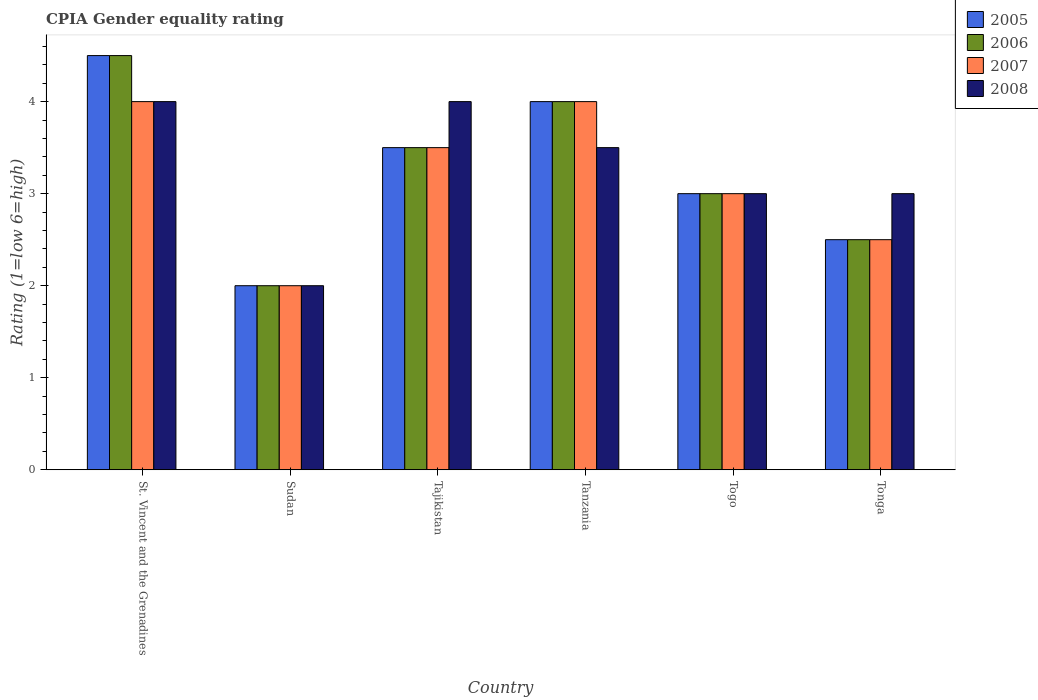How many groups of bars are there?
Keep it short and to the point. 6. How many bars are there on the 5th tick from the right?
Give a very brief answer. 4. What is the label of the 5th group of bars from the left?
Your answer should be very brief. Togo. In which country was the CPIA rating in 2007 maximum?
Provide a short and direct response. St. Vincent and the Grenadines. In which country was the CPIA rating in 2007 minimum?
Make the answer very short. Sudan. What is the total CPIA rating in 2007 in the graph?
Offer a very short reply. 19. What is the difference between the CPIA rating in 2007 in Sudan and that in Tanzania?
Provide a short and direct response. -2. What is the difference between the CPIA rating in 2006 in Sudan and the CPIA rating in 2007 in Tanzania?
Offer a terse response. -2. What is the average CPIA rating in 2006 per country?
Give a very brief answer. 3.25. What is the ratio of the CPIA rating in 2005 in Sudan to that in Tonga?
Offer a very short reply. 0.8. In how many countries, is the CPIA rating in 2005 greater than the average CPIA rating in 2005 taken over all countries?
Provide a succinct answer. 3. What does the 2nd bar from the left in St. Vincent and the Grenadines represents?
Keep it short and to the point. 2006. What does the 2nd bar from the right in Tonga represents?
Ensure brevity in your answer.  2007. Is it the case that in every country, the sum of the CPIA rating in 2007 and CPIA rating in 2006 is greater than the CPIA rating in 2008?
Provide a short and direct response. Yes. Does the graph contain grids?
Offer a very short reply. No. How many legend labels are there?
Your answer should be very brief. 4. What is the title of the graph?
Offer a very short reply. CPIA Gender equality rating. Does "2007" appear as one of the legend labels in the graph?
Your response must be concise. Yes. What is the label or title of the X-axis?
Your answer should be very brief. Country. What is the label or title of the Y-axis?
Your answer should be very brief. Rating (1=low 6=high). What is the Rating (1=low 6=high) in 2005 in St. Vincent and the Grenadines?
Ensure brevity in your answer.  4.5. What is the Rating (1=low 6=high) of 2006 in Sudan?
Ensure brevity in your answer.  2. What is the Rating (1=low 6=high) in 2007 in Sudan?
Provide a succinct answer. 2. What is the Rating (1=low 6=high) of 2008 in Sudan?
Provide a short and direct response. 2. What is the Rating (1=low 6=high) of 2005 in Tajikistan?
Offer a very short reply. 3.5. What is the Rating (1=low 6=high) in 2006 in Tanzania?
Keep it short and to the point. 4. What is the Rating (1=low 6=high) in 2007 in Tanzania?
Give a very brief answer. 4. What is the Rating (1=low 6=high) in 2008 in Tanzania?
Your response must be concise. 3.5. What is the Rating (1=low 6=high) in 2005 in Togo?
Provide a short and direct response. 3. What is the Rating (1=low 6=high) of 2008 in Togo?
Offer a terse response. 3. What is the Rating (1=low 6=high) of 2005 in Tonga?
Your answer should be compact. 2.5. Across all countries, what is the maximum Rating (1=low 6=high) of 2006?
Keep it short and to the point. 4.5. Across all countries, what is the maximum Rating (1=low 6=high) of 2007?
Offer a terse response. 4. Across all countries, what is the minimum Rating (1=low 6=high) in 2008?
Your answer should be compact. 2. What is the total Rating (1=low 6=high) in 2005 in the graph?
Your response must be concise. 19.5. What is the total Rating (1=low 6=high) of 2006 in the graph?
Your answer should be very brief. 19.5. What is the total Rating (1=low 6=high) of 2008 in the graph?
Your answer should be very brief. 19.5. What is the difference between the Rating (1=low 6=high) of 2005 in St. Vincent and the Grenadines and that in Sudan?
Offer a very short reply. 2.5. What is the difference between the Rating (1=low 6=high) in 2006 in St. Vincent and the Grenadines and that in Sudan?
Offer a terse response. 2.5. What is the difference between the Rating (1=low 6=high) in 2008 in St. Vincent and the Grenadines and that in Sudan?
Your answer should be compact. 2. What is the difference between the Rating (1=low 6=high) of 2005 in St. Vincent and the Grenadines and that in Tajikistan?
Ensure brevity in your answer.  1. What is the difference between the Rating (1=low 6=high) in 2006 in St. Vincent and the Grenadines and that in Tajikistan?
Give a very brief answer. 1. What is the difference between the Rating (1=low 6=high) in 2005 in St. Vincent and the Grenadines and that in Tanzania?
Your response must be concise. 0.5. What is the difference between the Rating (1=low 6=high) of 2006 in St. Vincent and the Grenadines and that in Tanzania?
Offer a very short reply. 0.5. What is the difference between the Rating (1=low 6=high) in 2007 in St. Vincent and the Grenadines and that in Tanzania?
Provide a short and direct response. 0. What is the difference between the Rating (1=low 6=high) in 2005 in St. Vincent and the Grenadines and that in Togo?
Give a very brief answer. 1.5. What is the difference between the Rating (1=low 6=high) in 2006 in St. Vincent and the Grenadines and that in Togo?
Keep it short and to the point. 1.5. What is the difference between the Rating (1=low 6=high) of 2007 in St. Vincent and the Grenadines and that in Togo?
Provide a short and direct response. 1. What is the difference between the Rating (1=low 6=high) in 2008 in St. Vincent and the Grenadines and that in Togo?
Keep it short and to the point. 1. What is the difference between the Rating (1=low 6=high) of 2007 in St. Vincent and the Grenadines and that in Tonga?
Your answer should be very brief. 1.5. What is the difference between the Rating (1=low 6=high) in 2008 in St. Vincent and the Grenadines and that in Tonga?
Offer a terse response. 1. What is the difference between the Rating (1=low 6=high) of 2005 in Sudan and that in Tajikistan?
Your answer should be very brief. -1.5. What is the difference between the Rating (1=low 6=high) in 2007 in Sudan and that in Tajikistan?
Offer a terse response. -1.5. What is the difference between the Rating (1=low 6=high) in 2008 in Sudan and that in Tajikistan?
Your answer should be very brief. -2. What is the difference between the Rating (1=low 6=high) of 2005 in Sudan and that in Tanzania?
Your answer should be compact. -2. What is the difference between the Rating (1=low 6=high) of 2007 in Sudan and that in Tanzania?
Give a very brief answer. -2. What is the difference between the Rating (1=low 6=high) in 2007 in Sudan and that in Togo?
Make the answer very short. -1. What is the difference between the Rating (1=low 6=high) of 2008 in Sudan and that in Togo?
Your answer should be compact. -1. What is the difference between the Rating (1=low 6=high) of 2005 in Sudan and that in Tonga?
Keep it short and to the point. -0.5. What is the difference between the Rating (1=low 6=high) of 2006 in Sudan and that in Tonga?
Ensure brevity in your answer.  -0.5. What is the difference between the Rating (1=low 6=high) in 2007 in Sudan and that in Tonga?
Ensure brevity in your answer.  -0.5. What is the difference between the Rating (1=low 6=high) in 2005 in Tajikistan and that in Tanzania?
Provide a short and direct response. -0.5. What is the difference between the Rating (1=low 6=high) in 2008 in Tajikistan and that in Togo?
Offer a very short reply. 1. What is the difference between the Rating (1=low 6=high) of 2005 in Tajikistan and that in Tonga?
Your answer should be very brief. 1. What is the difference between the Rating (1=low 6=high) of 2006 in Tajikistan and that in Tonga?
Provide a short and direct response. 1. What is the difference between the Rating (1=low 6=high) in 2007 in Tajikistan and that in Tonga?
Make the answer very short. 1. What is the difference between the Rating (1=low 6=high) in 2005 in Tanzania and that in Togo?
Provide a short and direct response. 1. What is the difference between the Rating (1=low 6=high) of 2007 in Tanzania and that in Togo?
Give a very brief answer. 1. What is the difference between the Rating (1=low 6=high) in 2008 in Tanzania and that in Togo?
Offer a terse response. 0.5. What is the difference between the Rating (1=low 6=high) of 2006 in Tanzania and that in Tonga?
Your answer should be compact. 1.5. What is the difference between the Rating (1=low 6=high) of 2005 in Togo and that in Tonga?
Make the answer very short. 0.5. What is the difference between the Rating (1=low 6=high) in 2005 in St. Vincent and the Grenadines and the Rating (1=low 6=high) in 2008 in Sudan?
Your response must be concise. 2.5. What is the difference between the Rating (1=low 6=high) in 2006 in St. Vincent and the Grenadines and the Rating (1=low 6=high) in 2007 in Sudan?
Offer a terse response. 2.5. What is the difference between the Rating (1=low 6=high) in 2007 in St. Vincent and the Grenadines and the Rating (1=low 6=high) in 2008 in Sudan?
Provide a succinct answer. 2. What is the difference between the Rating (1=low 6=high) in 2005 in St. Vincent and the Grenadines and the Rating (1=low 6=high) in 2006 in Tajikistan?
Your response must be concise. 1. What is the difference between the Rating (1=low 6=high) in 2005 in St. Vincent and the Grenadines and the Rating (1=low 6=high) in 2008 in Tajikistan?
Make the answer very short. 0.5. What is the difference between the Rating (1=low 6=high) in 2006 in St. Vincent and the Grenadines and the Rating (1=low 6=high) in 2007 in Tajikistan?
Keep it short and to the point. 1. What is the difference between the Rating (1=low 6=high) of 2006 in St. Vincent and the Grenadines and the Rating (1=low 6=high) of 2008 in Tajikistan?
Ensure brevity in your answer.  0.5. What is the difference between the Rating (1=low 6=high) in 2007 in St. Vincent and the Grenadines and the Rating (1=low 6=high) in 2008 in Tajikistan?
Make the answer very short. 0. What is the difference between the Rating (1=low 6=high) in 2005 in St. Vincent and the Grenadines and the Rating (1=low 6=high) in 2007 in Tanzania?
Ensure brevity in your answer.  0.5. What is the difference between the Rating (1=low 6=high) in 2005 in St. Vincent and the Grenadines and the Rating (1=low 6=high) in 2008 in Tanzania?
Make the answer very short. 1. What is the difference between the Rating (1=low 6=high) in 2006 in St. Vincent and the Grenadines and the Rating (1=low 6=high) in 2007 in Tanzania?
Provide a short and direct response. 0.5. What is the difference between the Rating (1=low 6=high) in 2005 in St. Vincent and the Grenadines and the Rating (1=low 6=high) in 2007 in Togo?
Ensure brevity in your answer.  1.5. What is the difference between the Rating (1=low 6=high) in 2005 in St. Vincent and the Grenadines and the Rating (1=low 6=high) in 2008 in Togo?
Keep it short and to the point. 1.5. What is the difference between the Rating (1=low 6=high) in 2006 in St. Vincent and the Grenadines and the Rating (1=low 6=high) in 2007 in Togo?
Give a very brief answer. 1.5. What is the difference between the Rating (1=low 6=high) of 2005 in St. Vincent and the Grenadines and the Rating (1=low 6=high) of 2007 in Tonga?
Your response must be concise. 2. What is the difference between the Rating (1=low 6=high) of 2005 in St. Vincent and the Grenadines and the Rating (1=low 6=high) of 2008 in Tonga?
Ensure brevity in your answer.  1.5. What is the difference between the Rating (1=low 6=high) of 2006 in St. Vincent and the Grenadines and the Rating (1=low 6=high) of 2007 in Tonga?
Your response must be concise. 2. What is the difference between the Rating (1=low 6=high) in 2006 in St. Vincent and the Grenadines and the Rating (1=low 6=high) in 2008 in Tonga?
Offer a terse response. 1.5. What is the difference between the Rating (1=low 6=high) in 2005 in Sudan and the Rating (1=low 6=high) in 2008 in Tajikistan?
Offer a terse response. -2. What is the difference between the Rating (1=low 6=high) in 2006 in Sudan and the Rating (1=low 6=high) in 2008 in Tajikistan?
Give a very brief answer. -2. What is the difference between the Rating (1=low 6=high) of 2007 in Sudan and the Rating (1=low 6=high) of 2008 in Tajikistan?
Keep it short and to the point. -2. What is the difference between the Rating (1=low 6=high) of 2005 in Sudan and the Rating (1=low 6=high) of 2006 in Tanzania?
Your answer should be very brief. -2. What is the difference between the Rating (1=low 6=high) of 2007 in Sudan and the Rating (1=low 6=high) of 2008 in Tanzania?
Give a very brief answer. -1.5. What is the difference between the Rating (1=low 6=high) in 2005 in Sudan and the Rating (1=low 6=high) in 2007 in Togo?
Offer a very short reply. -1. What is the difference between the Rating (1=low 6=high) of 2005 in Sudan and the Rating (1=low 6=high) of 2008 in Togo?
Give a very brief answer. -1. What is the difference between the Rating (1=low 6=high) in 2006 in Sudan and the Rating (1=low 6=high) in 2007 in Togo?
Give a very brief answer. -1. What is the difference between the Rating (1=low 6=high) in 2006 in Sudan and the Rating (1=low 6=high) in 2008 in Togo?
Make the answer very short. -1. What is the difference between the Rating (1=low 6=high) in 2007 in Sudan and the Rating (1=low 6=high) in 2008 in Togo?
Provide a short and direct response. -1. What is the difference between the Rating (1=low 6=high) in 2005 in Sudan and the Rating (1=low 6=high) in 2006 in Tonga?
Offer a very short reply. -0.5. What is the difference between the Rating (1=low 6=high) in 2005 in Sudan and the Rating (1=low 6=high) in 2007 in Tonga?
Keep it short and to the point. -0.5. What is the difference between the Rating (1=low 6=high) in 2005 in Tajikistan and the Rating (1=low 6=high) in 2006 in Tanzania?
Offer a very short reply. -0.5. What is the difference between the Rating (1=low 6=high) in 2005 in Tajikistan and the Rating (1=low 6=high) in 2007 in Tanzania?
Offer a very short reply. -0.5. What is the difference between the Rating (1=low 6=high) of 2005 in Tajikistan and the Rating (1=low 6=high) of 2008 in Tanzania?
Your response must be concise. 0. What is the difference between the Rating (1=low 6=high) in 2006 in Tajikistan and the Rating (1=low 6=high) in 2008 in Tanzania?
Keep it short and to the point. 0. What is the difference between the Rating (1=low 6=high) in 2006 in Tajikistan and the Rating (1=low 6=high) in 2007 in Togo?
Provide a succinct answer. 0.5. What is the difference between the Rating (1=low 6=high) in 2006 in Tajikistan and the Rating (1=low 6=high) in 2008 in Togo?
Provide a short and direct response. 0.5. What is the difference between the Rating (1=low 6=high) of 2007 in Tajikistan and the Rating (1=low 6=high) of 2008 in Togo?
Keep it short and to the point. 0.5. What is the difference between the Rating (1=low 6=high) of 2005 in Tajikistan and the Rating (1=low 6=high) of 2006 in Tonga?
Give a very brief answer. 1. What is the difference between the Rating (1=low 6=high) of 2005 in Tanzania and the Rating (1=low 6=high) of 2006 in Togo?
Your answer should be compact. 1. What is the difference between the Rating (1=low 6=high) in 2005 in Tanzania and the Rating (1=low 6=high) in 2007 in Tonga?
Your response must be concise. 1.5. What is the difference between the Rating (1=low 6=high) in 2006 in Tanzania and the Rating (1=low 6=high) in 2007 in Tonga?
Ensure brevity in your answer.  1.5. What is the difference between the Rating (1=low 6=high) in 2007 in Tanzania and the Rating (1=low 6=high) in 2008 in Tonga?
Your response must be concise. 1. What is the difference between the Rating (1=low 6=high) of 2005 in Togo and the Rating (1=low 6=high) of 2006 in Tonga?
Provide a short and direct response. 0.5. What is the difference between the Rating (1=low 6=high) in 2005 in Togo and the Rating (1=low 6=high) in 2008 in Tonga?
Give a very brief answer. 0. What is the difference between the Rating (1=low 6=high) in 2006 in Togo and the Rating (1=low 6=high) in 2008 in Tonga?
Give a very brief answer. 0. What is the average Rating (1=low 6=high) of 2007 per country?
Give a very brief answer. 3.17. What is the difference between the Rating (1=low 6=high) of 2005 and Rating (1=low 6=high) of 2006 in St. Vincent and the Grenadines?
Offer a terse response. 0. What is the difference between the Rating (1=low 6=high) in 2007 and Rating (1=low 6=high) in 2008 in St. Vincent and the Grenadines?
Ensure brevity in your answer.  0. What is the difference between the Rating (1=low 6=high) of 2006 and Rating (1=low 6=high) of 2007 in Sudan?
Your answer should be compact. 0. What is the difference between the Rating (1=low 6=high) of 2006 and Rating (1=low 6=high) of 2008 in Sudan?
Ensure brevity in your answer.  0. What is the difference between the Rating (1=low 6=high) in 2005 and Rating (1=low 6=high) in 2006 in Tajikistan?
Provide a short and direct response. 0. What is the difference between the Rating (1=low 6=high) of 2006 and Rating (1=low 6=high) of 2007 in Tajikistan?
Make the answer very short. 0. What is the difference between the Rating (1=low 6=high) of 2006 and Rating (1=low 6=high) of 2008 in Tajikistan?
Provide a succinct answer. -0.5. What is the difference between the Rating (1=low 6=high) in 2006 and Rating (1=low 6=high) in 2007 in Tanzania?
Offer a terse response. 0. What is the difference between the Rating (1=low 6=high) in 2005 and Rating (1=low 6=high) in 2006 in Togo?
Provide a succinct answer. 0. What is the difference between the Rating (1=low 6=high) of 2005 and Rating (1=low 6=high) of 2007 in Togo?
Your answer should be very brief. 0. What is the difference between the Rating (1=low 6=high) in 2005 and Rating (1=low 6=high) in 2008 in Togo?
Your answer should be compact. 0. What is the difference between the Rating (1=low 6=high) in 2007 and Rating (1=low 6=high) in 2008 in Togo?
Offer a terse response. 0. What is the difference between the Rating (1=low 6=high) of 2005 and Rating (1=low 6=high) of 2006 in Tonga?
Offer a very short reply. 0. What is the difference between the Rating (1=low 6=high) in 2005 and Rating (1=low 6=high) in 2007 in Tonga?
Offer a terse response. 0. What is the difference between the Rating (1=low 6=high) in 2005 and Rating (1=low 6=high) in 2008 in Tonga?
Offer a terse response. -0.5. What is the ratio of the Rating (1=low 6=high) of 2005 in St. Vincent and the Grenadines to that in Sudan?
Provide a short and direct response. 2.25. What is the ratio of the Rating (1=low 6=high) of 2006 in St. Vincent and the Grenadines to that in Sudan?
Make the answer very short. 2.25. What is the ratio of the Rating (1=low 6=high) of 2007 in St. Vincent and the Grenadines to that in Sudan?
Your answer should be compact. 2. What is the ratio of the Rating (1=low 6=high) in 2008 in St. Vincent and the Grenadines to that in Sudan?
Make the answer very short. 2. What is the ratio of the Rating (1=low 6=high) of 2006 in St. Vincent and the Grenadines to that in Tajikistan?
Provide a succinct answer. 1.29. What is the ratio of the Rating (1=low 6=high) in 2008 in St. Vincent and the Grenadines to that in Tajikistan?
Your answer should be very brief. 1. What is the ratio of the Rating (1=low 6=high) in 2006 in St. Vincent and the Grenadines to that in Tanzania?
Offer a terse response. 1.12. What is the ratio of the Rating (1=low 6=high) in 2007 in St. Vincent and the Grenadines to that in Tanzania?
Provide a short and direct response. 1. What is the ratio of the Rating (1=low 6=high) of 2008 in St. Vincent and the Grenadines to that in Tanzania?
Your answer should be very brief. 1.14. What is the ratio of the Rating (1=low 6=high) in 2005 in St. Vincent and the Grenadines to that in Togo?
Offer a terse response. 1.5. What is the ratio of the Rating (1=low 6=high) in 2006 in St. Vincent and the Grenadines to that in Togo?
Give a very brief answer. 1.5. What is the ratio of the Rating (1=low 6=high) of 2005 in St. Vincent and the Grenadines to that in Tonga?
Make the answer very short. 1.8. What is the ratio of the Rating (1=low 6=high) in 2007 in St. Vincent and the Grenadines to that in Tonga?
Make the answer very short. 1.6. What is the ratio of the Rating (1=low 6=high) in 2008 in St. Vincent and the Grenadines to that in Tonga?
Provide a succinct answer. 1.33. What is the ratio of the Rating (1=low 6=high) of 2005 in Sudan to that in Tajikistan?
Keep it short and to the point. 0.57. What is the ratio of the Rating (1=low 6=high) in 2006 in Sudan to that in Tajikistan?
Keep it short and to the point. 0.57. What is the ratio of the Rating (1=low 6=high) in 2006 in Sudan to that in Tanzania?
Ensure brevity in your answer.  0.5. What is the ratio of the Rating (1=low 6=high) in 2006 in Sudan to that in Togo?
Give a very brief answer. 0.67. What is the ratio of the Rating (1=low 6=high) of 2006 in Sudan to that in Tonga?
Offer a very short reply. 0.8. What is the ratio of the Rating (1=low 6=high) in 2005 in Tajikistan to that in Tanzania?
Offer a very short reply. 0.88. What is the ratio of the Rating (1=low 6=high) of 2006 in Tajikistan to that in Tanzania?
Your response must be concise. 0.88. What is the ratio of the Rating (1=low 6=high) in 2007 in Tajikistan to that in Tanzania?
Your answer should be compact. 0.88. What is the ratio of the Rating (1=low 6=high) of 2008 in Tajikistan to that in Tanzania?
Your answer should be compact. 1.14. What is the ratio of the Rating (1=low 6=high) of 2006 in Tajikistan to that in Togo?
Your answer should be compact. 1.17. What is the ratio of the Rating (1=low 6=high) in 2007 in Tajikistan to that in Togo?
Your answer should be very brief. 1.17. What is the ratio of the Rating (1=low 6=high) in 2005 in Tajikistan to that in Tonga?
Keep it short and to the point. 1.4. What is the ratio of the Rating (1=low 6=high) in 2006 in Tajikistan to that in Tonga?
Keep it short and to the point. 1.4. What is the ratio of the Rating (1=low 6=high) in 2007 in Tajikistan to that in Tonga?
Provide a succinct answer. 1.4. What is the ratio of the Rating (1=low 6=high) of 2007 in Tanzania to that in Togo?
Your answer should be compact. 1.33. What is the ratio of the Rating (1=low 6=high) in 2008 in Tanzania to that in Togo?
Give a very brief answer. 1.17. What is the ratio of the Rating (1=low 6=high) of 2006 in Tanzania to that in Tonga?
Keep it short and to the point. 1.6. What is the ratio of the Rating (1=low 6=high) in 2008 in Tanzania to that in Tonga?
Ensure brevity in your answer.  1.17. What is the ratio of the Rating (1=low 6=high) of 2005 in Togo to that in Tonga?
Keep it short and to the point. 1.2. What is the ratio of the Rating (1=low 6=high) in 2006 in Togo to that in Tonga?
Make the answer very short. 1.2. What is the ratio of the Rating (1=low 6=high) of 2007 in Togo to that in Tonga?
Ensure brevity in your answer.  1.2. What is the ratio of the Rating (1=low 6=high) of 2008 in Togo to that in Tonga?
Ensure brevity in your answer.  1. What is the difference between the highest and the second highest Rating (1=low 6=high) of 2007?
Keep it short and to the point. 0. What is the difference between the highest and the second highest Rating (1=low 6=high) in 2008?
Your answer should be compact. 0. What is the difference between the highest and the lowest Rating (1=low 6=high) of 2007?
Offer a very short reply. 2. What is the difference between the highest and the lowest Rating (1=low 6=high) of 2008?
Ensure brevity in your answer.  2. 